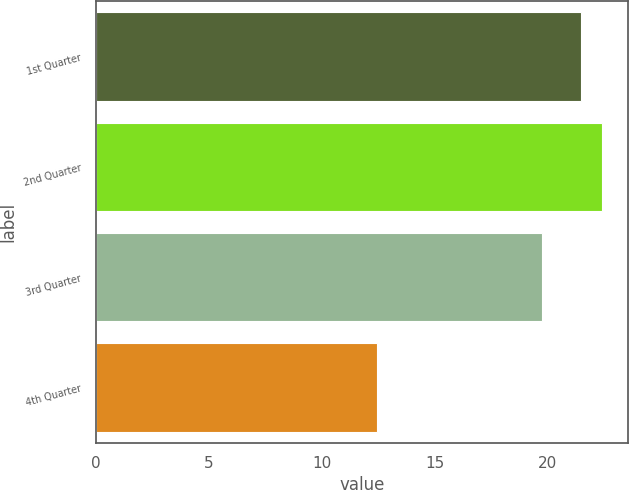Convert chart to OTSL. <chart><loc_0><loc_0><loc_500><loc_500><bar_chart><fcel>1st Quarter<fcel>2nd Quarter<fcel>3rd Quarter<fcel>4th Quarter<nl><fcel>21.51<fcel>22.44<fcel>19.76<fcel>12.46<nl></chart> 